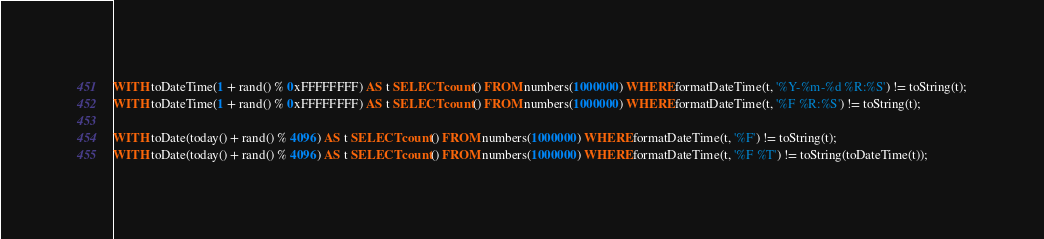<code> <loc_0><loc_0><loc_500><loc_500><_SQL_>WITH toDateTime(1 + rand() % 0xFFFFFFFF) AS t SELECT count() FROM numbers(1000000) WHERE formatDateTime(t, '%Y-%m-%d %R:%S') != toString(t);
WITH toDateTime(1 + rand() % 0xFFFFFFFF) AS t SELECT count() FROM numbers(1000000) WHERE formatDateTime(t, '%F %R:%S') != toString(t);

WITH toDate(today() + rand() % 4096) AS t SELECT count() FROM numbers(1000000) WHERE formatDateTime(t, '%F') != toString(t);
WITH toDate(today() + rand() % 4096) AS t SELECT count() FROM numbers(1000000) WHERE formatDateTime(t, '%F %T') != toString(toDateTime(t));
</code> 